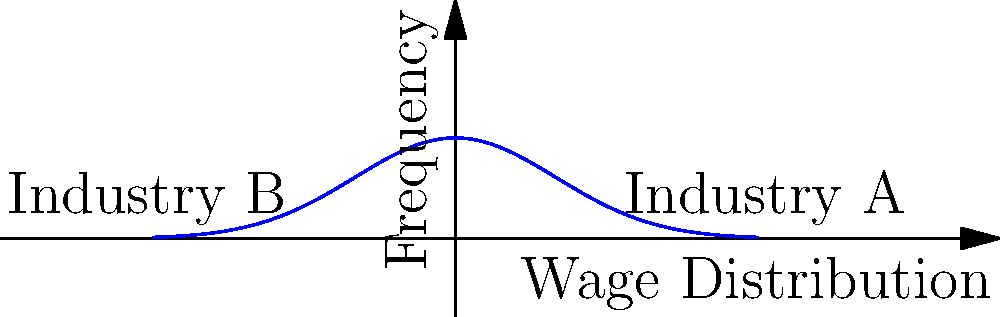Consider the surface representing wage distribution across industries, as shown in the graph. If we were to analyze the genus of this surface in a 3D representation where each industry forms a distinct peak, what would be the genus, and how does this relate to the concept of wage equality? To determine the genus of the surface and relate it to wage equality, let's follow these steps:

1. Interpret the graph: The graph shows a bimodal distribution of wages across industries, with two distinct peaks representing Industry A and Industry B.

2. Visualize the 3D representation: Imagine extending this 2D graph into 3D space, where each industry forms a peak or "hill" on the surface.

3. Count the number of holes: In topology, the genus of a surface is the number of holes or "handles" it has. In this case, there are no holes in the surface.

4. Determine the genus: The genus of this surface is 0, as it has no holes. It's topologically equivalent to a sphere with multiple peaks.

5. Relate to wage equality: 
   - Each peak represents a concentration of wages in a particular industry.
   - The presence of multiple peaks (in this case, two) indicates wage inequality between industries.
   - A surface with genus 0 but multiple peaks suggests distinct wage distributions that do not "connect" smoothly, indicating potential barriers or gaps between industry wages.

6. Interpretation for labor rights: As a labor rights lawyer, this analysis suggests that there are significant wage disparities between industries that need to be addressed to promote fair working conditions across sectors.
Answer: Genus 0; multiple peaks indicate wage inequality between industries 